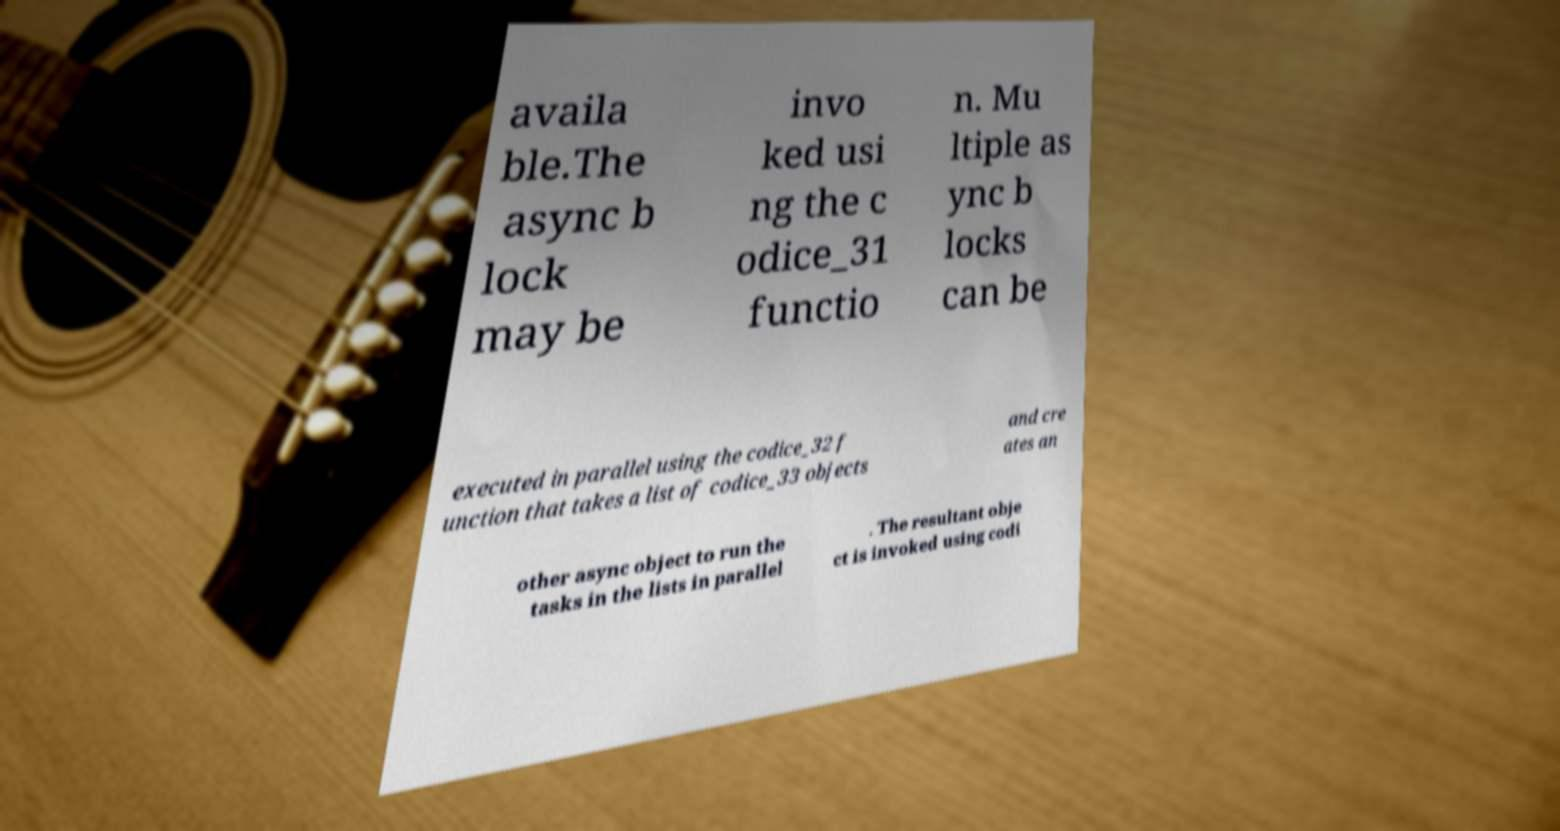Could you extract and type out the text from this image? availa ble.The async b lock may be invo ked usi ng the c odice_31 functio n. Mu ltiple as ync b locks can be executed in parallel using the codice_32 f unction that takes a list of codice_33 objects and cre ates an other async object to run the tasks in the lists in parallel . The resultant obje ct is invoked using codi 